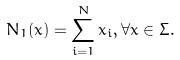Convert formula to latex. <formula><loc_0><loc_0><loc_500><loc_500>N _ { 1 } ( x ) = \sum _ { i = 1 } ^ { N } x _ { i } , \forall x \in \Sigma .</formula> 